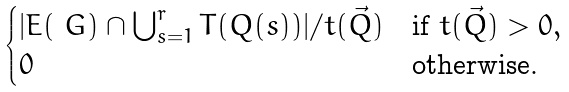Convert formula to latex. <formula><loc_0><loc_0><loc_500><loc_500>\begin{cases} | E ( \ G ) \cap \bigcup _ { s = 1 } ^ { r } T ( Q ( s ) ) | / t ( \vec { Q } ) & \text {if } t ( \vec { Q } ) > 0 , \\ 0 & \text {otherwise.} \end{cases}</formula> 